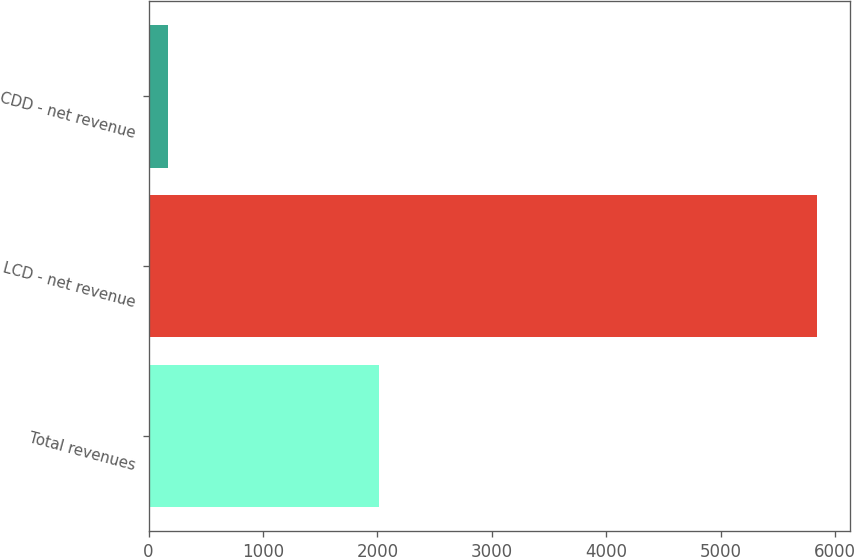<chart> <loc_0><loc_0><loc_500><loc_500><bar_chart><fcel>Total revenues<fcel>LCD - net revenue<fcel>CDD - net revenue<nl><fcel>2014<fcel>5838<fcel>173.6<nl></chart> 